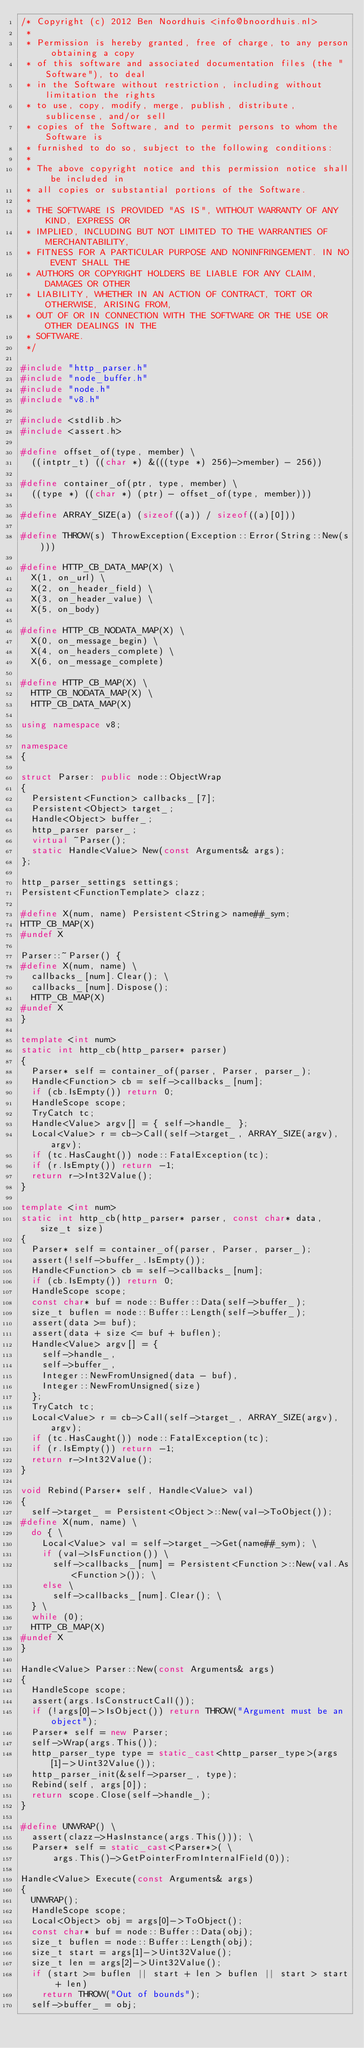Convert code to text. <code><loc_0><loc_0><loc_500><loc_500><_C++_>/* Copyright (c) 2012 Ben Noordhuis <info@bnoordhuis.nl>
 *
 * Permission is hereby granted, free of charge, to any person obtaining a copy
 * of this software and associated documentation files (the "Software"), to deal
 * in the Software without restriction, including without limitation the rights
 * to use, copy, modify, merge, publish, distribute, sublicense, and/or sell
 * copies of the Software, and to permit persons to whom the Software is
 * furnished to do so, subject to the following conditions:
 *
 * The above copyright notice and this permission notice shall be included in
 * all copies or substantial portions of the Software.
 *
 * THE SOFTWARE IS PROVIDED "AS IS", WITHOUT WARRANTY OF ANY KIND, EXPRESS OR
 * IMPLIED, INCLUDING BUT NOT LIMITED TO THE WARRANTIES OF MERCHANTABILITY,
 * FITNESS FOR A PARTICULAR PURPOSE AND NONINFRINGEMENT. IN NO EVENT SHALL THE
 * AUTHORS OR COPYRIGHT HOLDERS BE LIABLE FOR ANY CLAIM, DAMAGES OR OTHER
 * LIABILITY, WHETHER IN AN ACTION OF CONTRACT, TORT OR OTHERWISE, ARISING FROM,
 * OUT OF OR IN CONNECTION WITH THE SOFTWARE OR THE USE OR OTHER DEALINGS IN THE
 * SOFTWARE.
 */

#include "http_parser.h"
#include "node_buffer.h"
#include "node.h"
#include "v8.h"

#include <stdlib.h>
#include <assert.h>

#define offset_of(type, member) \
  ((intptr_t) ((char *) &(((type *) 256)->member) - 256))

#define container_of(ptr, type, member) \
  ((type *) ((char *) (ptr) - offset_of(type, member)))

#define ARRAY_SIZE(a) (sizeof((a)) / sizeof((a)[0]))

#define THROW(s) ThrowException(Exception::Error(String::New(s)))

#define HTTP_CB_DATA_MAP(X) \
  X(1, on_url) \
  X(2, on_header_field) \
  X(3, on_header_value) \
  X(5, on_body)

#define HTTP_CB_NODATA_MAP(X) \
  X(0, on_message_begin) \
  X(4, on_headers_complete) \
  X(6, on_message_complete)

#define HTTP_CB_MAP(X) \
  HTTP_CB_NODATA_MAP(X) \
  HTTP_CB_DATA_MAP(X)

using namespace v8;

namespace
{

struct Parser: public node::ObjectWrap
{
  Persistent<Function> callbacks_[7];
  Persistent<Object> target_;
  Handle<Object> buffer_;
  http_parser parser_;
  virtual ~Parser();
  static Handle<Value> New(const Arguments& args);
};

http_parser_settings settings;
Persistent<FunctionTemplate> clazz;

#define X(num, name) Persistent<String> name##_sym;
HTTP_CB_MAP(X)
#undef X

Parser::~Parser() {
#define X(num, name) \
  callbacks_[num].Clear(); \
  callbacks_[num].Dispose();
  HTTP_CB_MAP(X)
#undef X
}

template <int num>
static int http_cb(http_parser* parser)
{
  Parser* self = container_of(parser, Parser, parser_);
  Handle<Function> cb = self->callbacks_[num];
  if (cb.IsEmpty()) return 0;
  HandleScope scope;
  TryCatch tc;
  Handle<Value> argv[] = { self->handle_ };
  Local<Value> r = cb->Call(self->target_, ARRAY_SIZE(argv), argv);
  if (tc.HasCaught()) node::FatalException(tc);
  if (r.IsEmpty()) return -1;
  return r->Int32Value();
}

template <int num>
static int http_cb(http_parser* parser, const char* data, size_t size)
{
  Parser* self = container_of(parser, Parser, parser_);
  assert(!self->buffer_.IsEmpty());
  Handle<Function> cb = self->callbacks_[num];
  if (cb.IsEmpty()) return 0;
  HandleScope scope;
  const char* buf = node::Buffer::Data(self->buffer_);
  size_t buflen = node::Buffer::Length(self->buffer_);
  assert(data >= buf);
  assert(data + size <= buf + buflen);
  Handle<Value> argv[] = {
    self->handle_,
    self->buffer_,
    Integer::NewFromUnsigned(data - buf),
    Integer::NewFromUnsigned(size)
  };
  TryCatch tc;
  Local<Value> r = cb->Call(self->target_, ARRAY_SIZE(argv), argv);
  if (tc.HasCaught()) node::FatalException(tc);
  if (r.IsEmpty()) return -1;
  return r->Int32Value();
}

void Rebind(Parser* self, Handle<Value> val)
{
  self->target_ = Persistent<Object>::New(val->ToObject());
#define X(num, name) \
  do { \
    Local<Value> val = self->target_->Get(name##_sym); \
    if (val->IsFunction()) \
      self->callbacks_[num] = Persistent<Function>::New(val.As<Function>()); \
    else \
      self->callbacks_[num].Clear(); \
  } \
  while (0);
  HTTP_CB_MAP(X)
#undef X
}

Handle<Value> Parser::New(const Arguments& args)
{
  HandleScope scope;
  assert(args.IsConstructCall());
  if (!args[0]->IsObject()) return THROW("Argument must be an object");
  Parser* self = new Parser;
  self->Wrap(args.This());
  http_parser_type type = static_cast<http_parser_type>(args[1]->Uint32Value());
  http_parser_init(&self->parser_, type);
  Rebind(self, args[0]);
  return scope.Close(self->handle_);
}

#define UNWRAP() \
  assert(clazz->HasInstance(args.This())); \
  Parser* self = static_cast<Parser*>( \
      args.This()->GetPointerFromInternalField(0));

Handle<Value> Execute(const Arguments& args)
{
  UNWRAP();
  HandleScope scope;
  Local<Object> obj = args[0]->ToObject();
  const char* buf = node::Buffer::Data(obj);
  size_t buflen = node::Buffer::Length(obj);
  size_t start = args[1]->Uint32Value();
  size_t len = args[2]->Uint32Value();
  if (start >= buflen || start + len > buflen || start > start + len)
    return THROW("Out of bounds");
  self->buffer_ = obj;</code> 